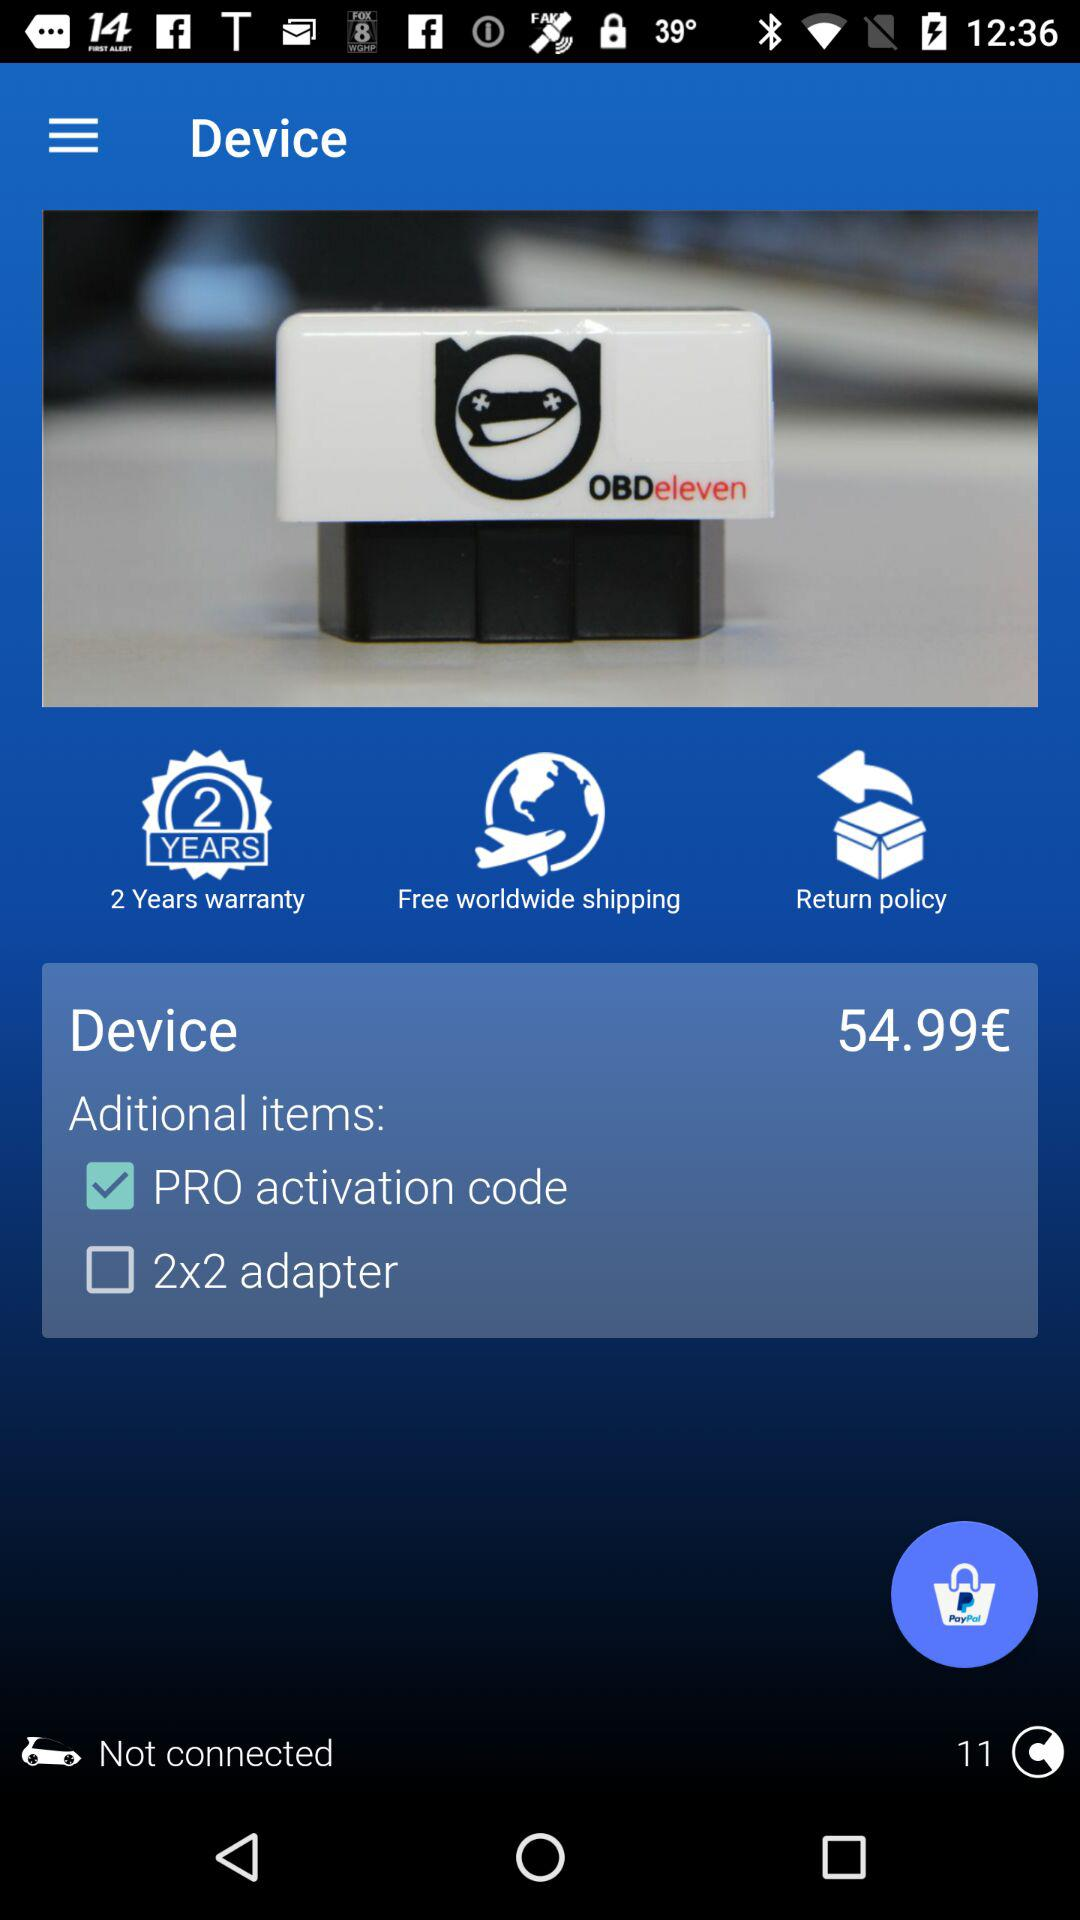How many years' warranty is given for the device? The warranty is given for 2 years. 